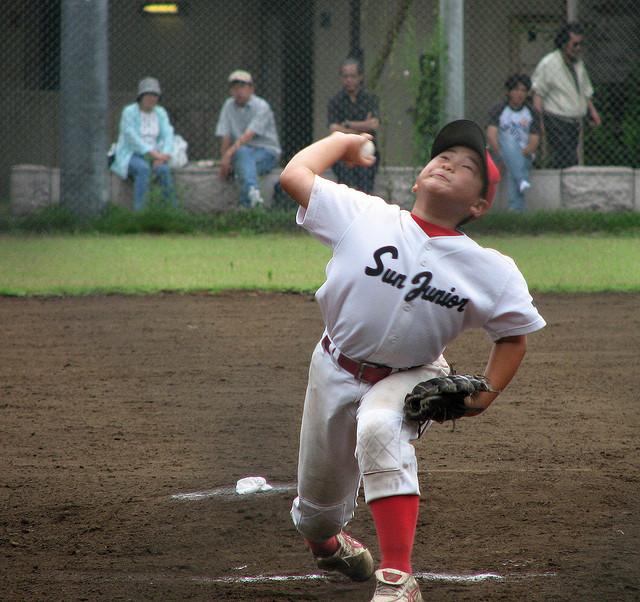How old is the child?
Keep it brief. 10. What is the team name?
Be succinct. Sun junior. What does his shirt say?
Concise answer only. Sun junior. What position is the child playing?
Short answer required. Pitcher. 